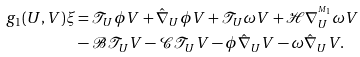<formula> <loc_0><loc_0><loc_500><loc_500>g _ { 1 } ( U , V ) \xi & = \mathcal { T } _ { U } \phi V + \hat { \nabla } _ { U } \phi V + \mathcal { T } _ { U } \omega V + \mathcal { H } \nabla ^ { ^ { M _ { 1 } } } _ { U } \omega V \\ & - \mathcal { B } \mathcal { T } _ { U } V - \mathcal { C } \mathcal { T } _ { U } V - \phi \hat { \nabla } _ { U } V - \omega \hat { \nabla } _ { U } V .</formula> 